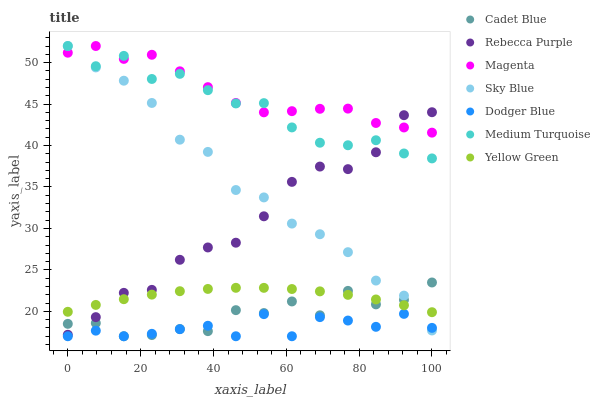Does Dodger Blue have the minimum area under the curve?
Answer yes or no. Yes. Does Magenta have the maximum area under the curve?
Answer yes or no. Yes. Does Yellow Green have the minimum area under the curve?
Answer yes or no. No. Does Yellow Green have the maximum area under the curve?
Answer yes or no. No. Is Yellow Green the smoothest?
Answer yes or no. Yes. Is Cadet Blue the roughest?
Answer yes or no. Yes. Is Dodger Blue the smoothest?
Answer yes or no. No. Is Dodger Blue the roughest?
Answer yes or no. No. Does Cadet Blue have the lowest value?
Answer yes or no. Yes. Does Yellow Green have the lowest value?
Answer yes or no. No. Does Magenta have the highest value?
Answer yes or no. Yes. Does Yellow Green have the highest value?
Answer yes or no. No. Is Dodger Blue less than Medium Turquoise?
Answer yes or no. Yes. Is Rebecca Purple greater than Dodger Blue?
Answer yes or no. Yes. Does Dodger Blue intersect Sky Blue?
Answer yes or no. Yes. Is Dodger Blue less than Sky Blue?
Answer yes or no. No. Is Dodger Blue greater than Sky Blue?
Answer yes or no. No. Does Dodger Blue intersect Medium Turquoise?
Answer yes or no. No. 